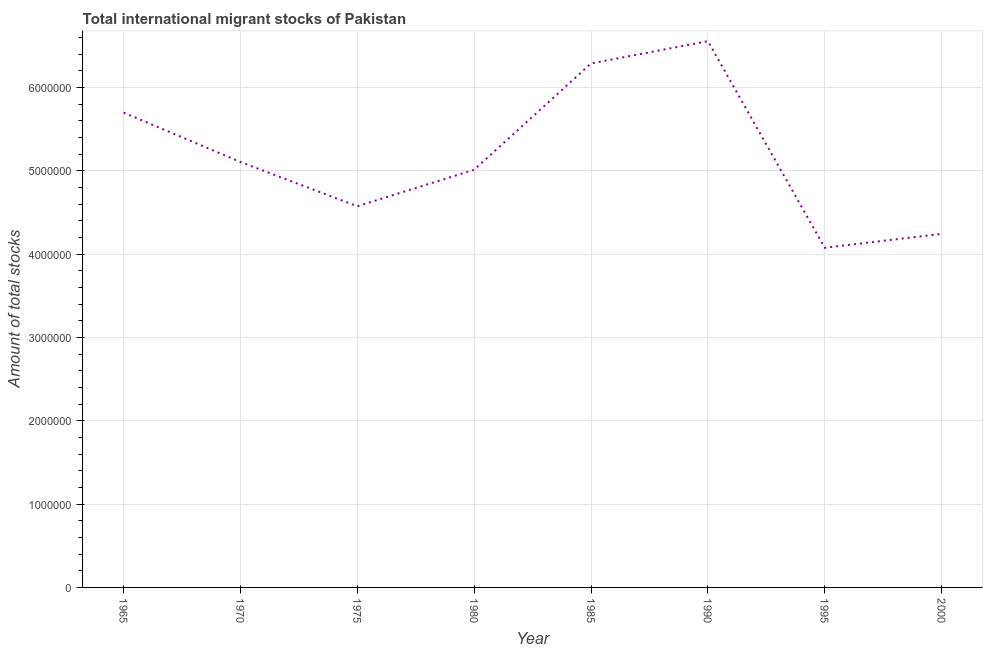What is the total number of international migrant stock in 2000?
Provide a short and direct response. 4.24e+06. Across all years, what is the maximum total number of international migrant stock?
Make the answer very short. 6.56e+06. Across all years, what is the minimum total number of international migrant stock?
Make the answer very short. 4.08e+06. In which year was the total number of international migrant stock maximum?
Your response must be concise. 1990. In which year was the total number of international migrant stock minimum?
Ensure brevity in your answer.  1995. What is the sum of the total number of international migrant stock?
Your answer should be compact. 4.16e+07. What is the difference between the total number of international migrant stock in 1990 and 2000?
Give a very brief answer. 2.31e+06. What is the average total number of international migrant stock per year?
Offer a terse response. 5.19e+06. What is the median total number of international migrant stock?
Provide a short and direct response. 5.06e+06. In how many years, is the total number of international migrant stock greater than 3600000 ?
Offer a very short reply. 8. Do a majority of the years between 1970 and 1965 (inclusive) have total number of international migrant stock greater than 2800000 ?
Keep it short and to the point. No. What is the ratio of the total number of international migrant stock in 1965 to that in 1990?
Your response must be concise. 0.87. Is the total number of international migrant stock in 1990 less than that in 1995?
Give a very brief answer. No. Is the difference between the total number of international migrant stock in 1975 and 2000 greater than the difference between any two years?
Give a very brief answer. No. What is the difference between the highest and the second highest total number of international migrant stock?
Make the answer very short. 2.68e+05. What is the difference between the highest and the lowest total number of international migrant stock?
Provide a short and direct response. 2.48e+06. How many lines are there?
Your answer should be compact. 1. How many years are there in the graph?
Keep it short and to the point. 8. Does the graph contain any zero values?
Provide a short and direct response. No. What is the title of the graph?
Provide a short and direct response. Total international migrant stocks of Pakistan. What is the label or title of the X-axis?
Offer a terse response. Year. What is the label or title of the Y-axis?
Ensure brevity in your answer.  Amount of total stocks. What is the Amount of total stocks of 1965?
Provide a succinct answer. 5.70e+06. What is the Amount of total stocks of 1970?
Keep it short and to the point. 5.11e+06. What is the Amount of total stocks in 1975?
Offer a terse response. 4.57e+06. What is the Amount of total stocks of 1980?
Keep it short and to the point. 5.01e+06. What is the Amount of total stocks of 1985?
Provide a short and direct response. 6.29e+06. What is the Amount of total stocks in 1990?
Provide a short and direct response. 6.56e+06. What is the Amount of total stocks of 1995?
Offer a terse response. 4.08e+06. What is the Amount of total stocks in 2000?
Keep it short and to the point. 4.24e+06. What is the difference between the Amount of total stocks in 1965 and 1970?
Provide a succinct answer. 5.93e+05. What is the difference between the Amount of total stocks in 1965 and 1975?
Your answer should be compact. 1.12e+06. What is the difference between the Amount of total stocks in 1965 and 1980?
Give a very brief answer. 6.86e+05. What is the difference between the Amount of total stocks in 1965 and 1985?
Your response must be concise. -5.90e+05. What is the difference between the Amount of total stocks in 1965 and 1990?
Offer a terse response. -8.57e+05. What is the difference between the Amount of total stocks in 1965 and 1995?
Your answer should be compact. 1.62e+06. What is the difference between the Amount of total stocks in 1965 and 2000?
Provide a succinct answer. 1.46e+06. What is the difference between the Amount of total stocks in 1970 and 1975?
Provide a short and direct response. 5.31e+05. What is the difference between the Amount of total stocks in 1970 and 1980?
Keep it short and to the point. 9.30e+04. What is the difference between the Amount of total stocks in 1970 and 1985?
Ensure brevity in your answer.  -1.18e+06. What is the difference between the Amount of total stocks in 1970 and 1990?
Ensure brevity in your answer.  -1.45e+06. What is the difference between the Amount of total stocks in 1970 and 1995?
Provide a succinct answer. 1.03e+06. What is the difference between the Amount of total stocks in 1970 and 2000?
Keep it short and to the point. 8.63e+05. What is the difference between the Amount of total stocks in 1975 and 1980?
Provide a succinct answer. -4.38e+05. What is the difference between the Amount of total stocks in 1975 and 1985?
Provide a short and direct response. -1.71e+06. What is the difference between the Amount of total stocks in 1975 and 1990?
Make the answer very short. -1.98e+06. What is the difference between the Amount of total stocks in 1975 and 1995?
Your answer should be very brief. 4.98e+05. What is the difference between the Amount of total stocks in 1975 and 2000?
Offer a terse response. 3.32e+05. What is the difference between the Amount of total stocks in 1980 and 1985?
Give a very brief answer. -1.28e+06. What is the difference between the Amount of total stocks in 1980 and 1990?
Offer a very short reply. -1.54e+06. What is the difference between the Amount of total stocks in 1980 and 1995?
Your response must be concise. 9.36e+05. What is the difference between the Amount of total stocks in 1980 and 2000?
Give a very brief answer. 7.70e+05. What is the difference between the Amount of total stocks in 1985 and 1990?
Ensure brevity in your answer.  -2.68e+05. What is the difference between the Amount of total stocks in 1985 and 1995?
Offer a very short reply. 2.21e+06. What is the difference between the Amount of total stocks in 1985 and 2000?
Offer a very short reply. 2.05e+06. What is the difference between the Amount of total stocks in 1990 and 1995?
Provide a succinct answer. 2.48e+06. What is the difference between the Amount of total stocks in 1990 and 2000?
Offer a very short reply. 2.31e+06. What is the difference between the Amount of total stocks in 1995 and 2000?
Offer a terse response. -1.66e+05. What is the ratio of the Amount of total stocks in 1965 to that in 1970?
Ensure brevity in your answer.  1.12. What is the ratio of the Amount of total stocks in 1965 to that in 1975?
Your response must be concise. 1.25. What is the ratio of the Amount of total stocks in 1965 to that in 1980?
Your response must be concise. 1.14. What is the ratio of the Amount of total stocks in 1965 to that in 1985?
Your answer should be very brief. 0.91. What is the ratio of the Amount of total stocks in 1965 to that in 1990?
Make the answer very short. 0.87. What is the ratio of the Amount of total stocks in 1965 to that in 1995?
Keep it short and to the point. 1.4. What is the ratio of the Amount of total stocks in 1965 to that in 2000?
Give a very brief answer. 1.34. What is the ratio of the Amount of total stocks in 1970 to that in 1975?
Give a very brief answer. 1.12. What is the ratio of the Amount of total stocks in 1970 to that in 1985?
Offer a very short reply. 0.81. What is the ratio of the Amount of total stocks in 1970 to that in 1990?
Provide a succinct answer. 0.78. What is the ratio of the Amount of total stocks in 1970 to that in 1995?
Keep it short and to the point. 1.25. What is the ratio of the Amount of total stocks in 1970 to that in 2000?
Keep it short and to the point. 1.2. What is the ratio of the Amount of total stocks in 1975 to that in 1985?
Your response must be concise. 0.73. What is the ratio of the Amount of total stocks in 1975 to that in 1990?
Offer a terse response. 0.7. What is the ratio of the Amount of total stocks in 1975 to that in 1995?
Provide a short and direct response. 1.12. What is the ratio of the Amount of total stocks in 1975 to that in 2000?
Provide a succinct answer. 1.08. What is the ratio of the Amount of total stocks in 1980 to that in 1985?
Provide a short and direct response. 0.8. What is the ratio of the Amount of total stocks in 1980 to that in 1990?
Offer a very short reply. 0.77. What is the ratio of the Amount of total stocks in 1980 to that in 1995?
Keep it short and to the point. 1.23. What is the ratio of the Amount of total stocks in 1980 to that in 2000?
Ensure brevity in your answer.  1.18. What is the ratio of the Amount of total stocks in 1985 to that in 1990?
Make the answer very short. 0.96. What is the ratio of the Amount of total stocks in 1985 to that in 1995?
Your answer should be very brief. 1.54. What is the ratio of the Amount of total stocks in 1985 to that in 2000?
Provide a succinct answer. 1.48. What is the ratio of the Amount of total stocks in 1990 to that in 1995?
Your answer should be very brief. 1.61. What is the ratio of the Amount of total stocks in 1990 to that in 2000?
Give a very brief answer. 1.54. 